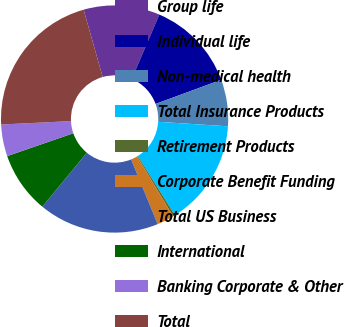<chart> <loc_0><loc_0><loc_500><loc_500><pie_chart><fcel>Group life<fcel>Individual life<fcel>Non-medical health<fcel>Total Insurance Products<fcel>Retirement Products<fcel>Corporate Benefit Funding<fcel>Total US Business<fcel>International<fcel>Banking Corporate & Other<fcel>Total<nl><fcel>10.84%<fcel>12.95%<fcel>6.63%<fcel>15.06%<fcel>0.31%<fcel>2.42%<fcel>17.16%<fcel>8.74%<fcel>4.52%<fcel>21.38%<nl></chart> 